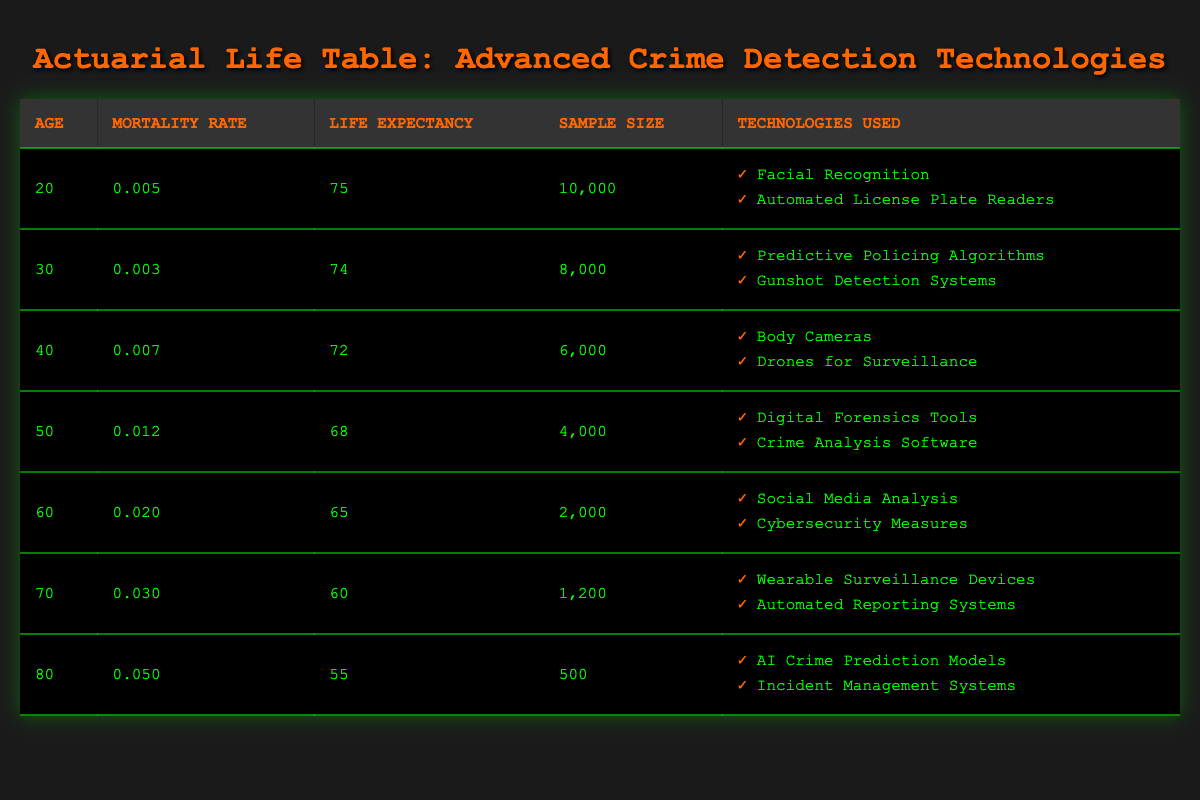What is the mortality rate for individuals aged 40? The table shows a specific data point for individuals of age 40, where the mortality rate is listed as 0.007.
Answer: 0.007 What is the life expectancy of individuals aged 50? For individuals aged 50, the life expectancy is provided in the table, which states 68 years.
Answer: 68 Which age group has the highest mortality rate? By comparing the mortality rates from the table, the age group of 80 has the highest rate at 0.050.
Answer: 80 What is the average life expectancy of individuals aged 30, 40, and 50? The life expectancies for these ages are 74 (30), 72 (40), and 68 (50). Summing these gives 74 + 72 + 68 = 214, and then dividing by 3 gives the average: 214 / 3 = approximately 71.33.
Answer: 71.33 Does the table indicate that individuals using AI crime prediction models have a higher mortality rate than those aged 60? The mortality rate for individuals aged 80 using AI crime prediction models is 0.050, while the rate for those aged 60 is 0.020. Since 0.050 is greater than 0.020, the answer is yes.
Answer: Yes What is the total sample size of individuals aged 30 and 40? From the table, the sample sizes are stated as 8,000 for age 30 and 6,000 for age 40. Adding these together gives 8,000 + 6,000 = 14,000.
Answer: 14,000 How many technologies are listed for individuals aged 70? The technologies used for individuals aged 70 are two: "Wearable Surveillance Devices" and "Automated Reporting Systems". Thus, the count is 2 technologies.
Answer: 2 Is the life expectancy for individuals aged 60 higher than that for individuals aged 80? The life expectancy for individuals aged 60 is 65 years while for those aged 80 it is 55 years. Since 65 is greater than 55, the statement is true.
Answer: Yes What is the difference in mortality rates between individuals aged 50 and 70? The mortality rate for individuals aged 50 is 0.012 and for those aged 70 is 0.030. The difference is 0.030 - 0.012 = 0.018.
Answer: 0.018 